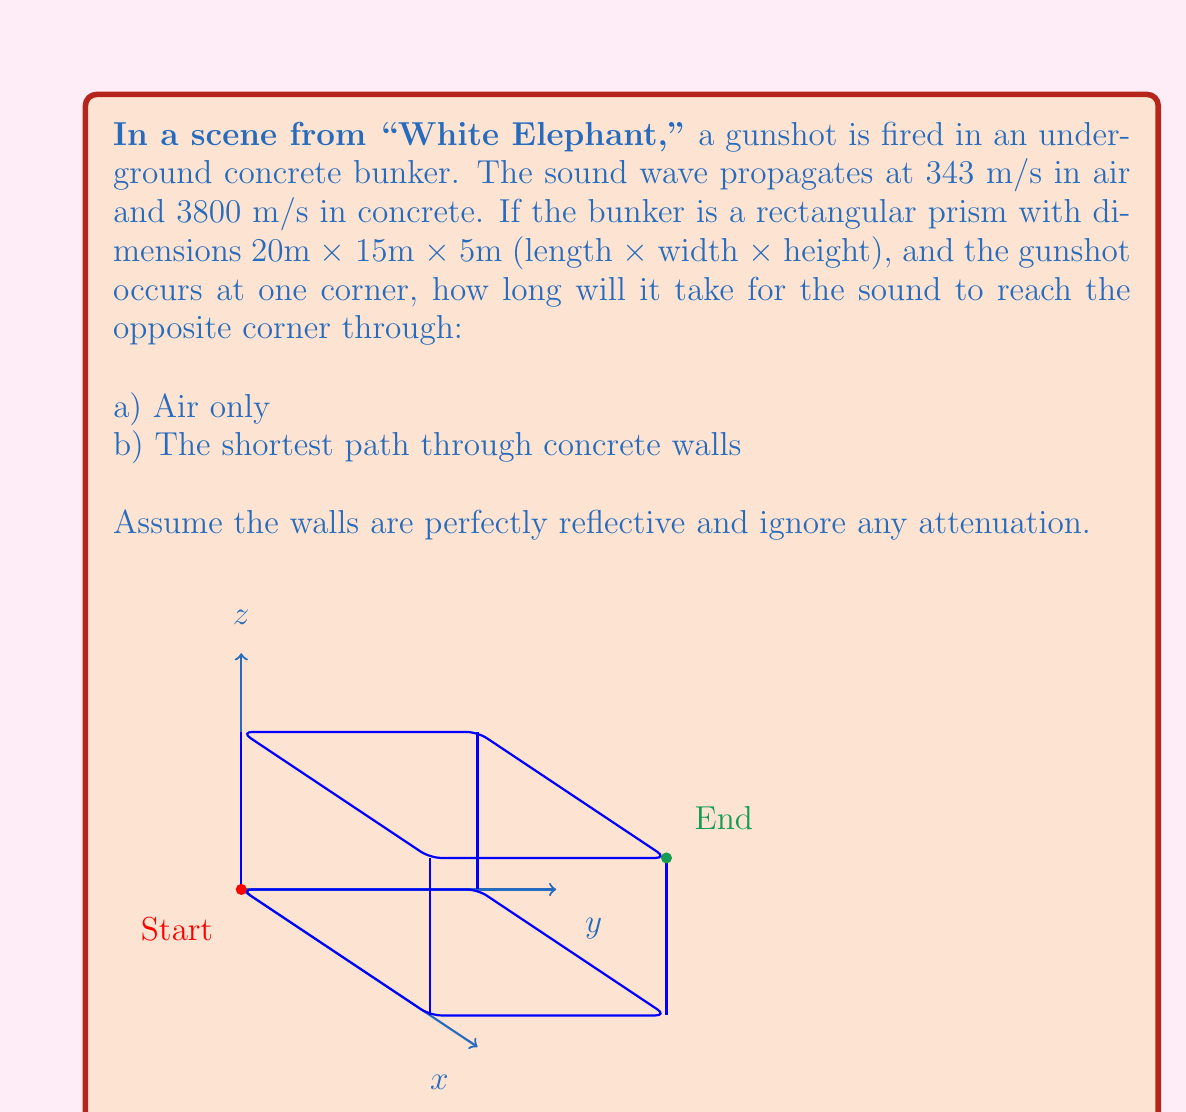Give your solution to this math problem. Let's approach this step-by-step:

1) For part a) (through air only):
   The sound travels diagonally across the bunker. We can calculate this distance using the 3D Pythagorean theorem:

   $$d = \sqrt{20^2 + 15^2 + 5^2} = \sqrt{400 + 225 + 25} = \sqrt{650} \approx 25.50 \text{ m}$$

   Time taken = Distance / Speed
   $$t_a = \frac{25.50}{343} \approx 0.0743 \text{ s}$$

2) For part b) (shortest path through concrete):
   The shortest path will be along the edges of the bunker. This forms a right-angled path with three segments:

   $$d_1 = 20 \text{ m}, d_2 = 15 \text{ m}, d_3 = 5 \text{ m}$$

   Total distance = $20 + 15 + 5 = 40 \text{ m}$

   Time taken = Distance / Speed
   $$t_b = \frac{40}{3800} \approx 0.0105 \text{ s}$$

3) Comparing the results:
   The sound travels much faster through the concrete walls (about 7 times faster) despite the longer path, due to the higher speed of sound in concrete.

This analysis is crucial for accurate sound design in films like "White Elephant," ensuring that the audio timing matches the visual representation of the space.
Answer: a) 0.0743 s
b) 0.0105 s 